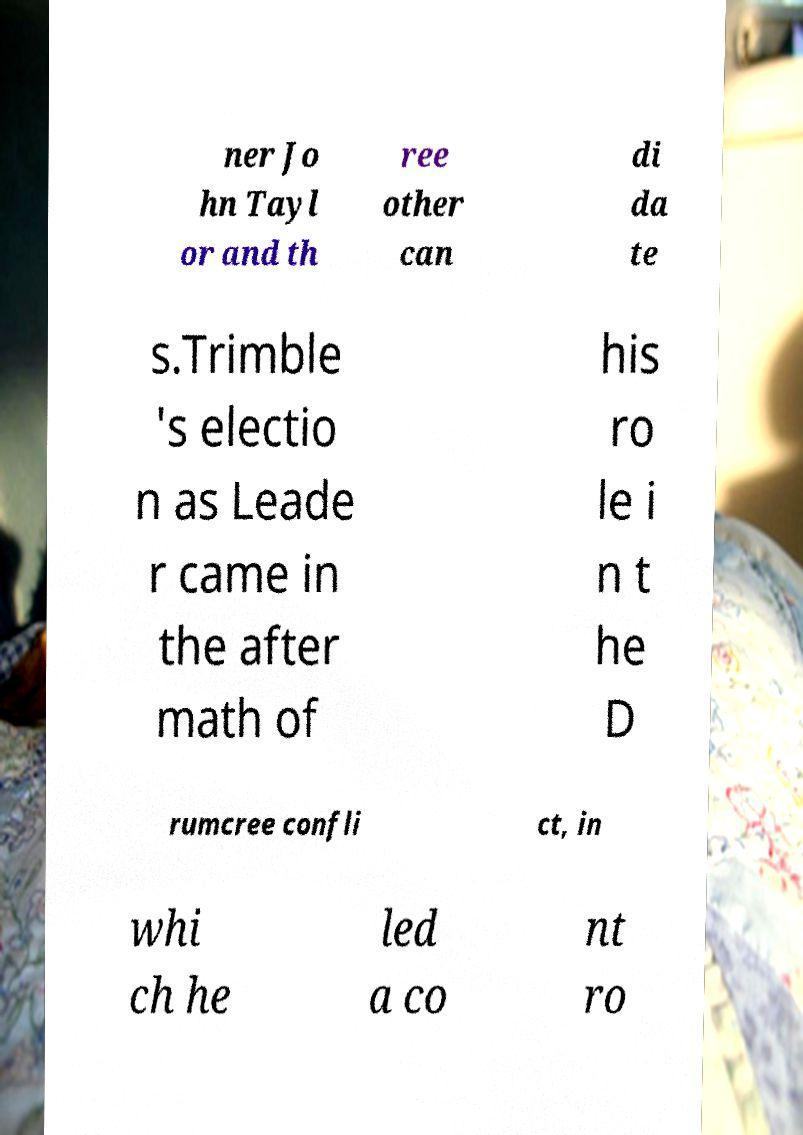For documentation purposes, I need the text within this image transcribed. Could you provide that? ner Jo hn Tayl or and th ree other can di da te s.Trimble 's electio n as Leade r came in the after math of his ro le i n t he D rumcree confli ct, in whi ch he led a co nt ro 